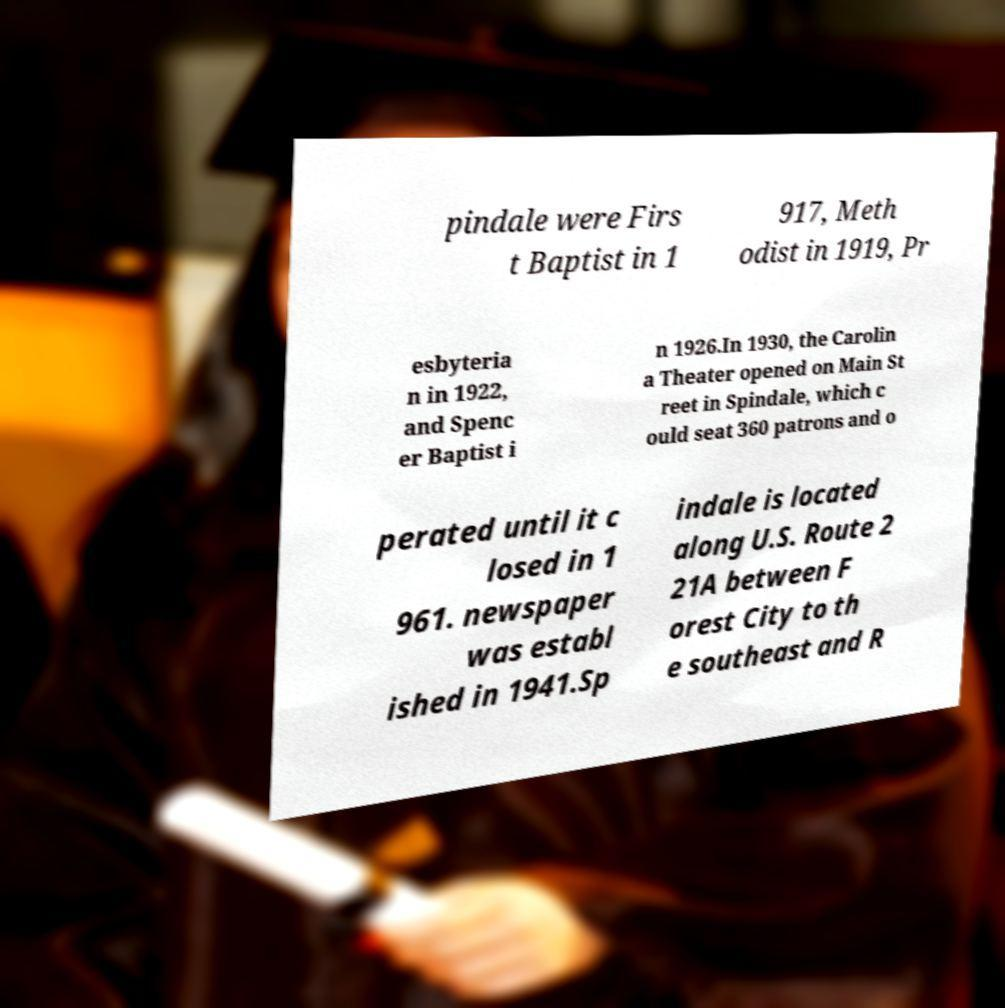Can you read and provide the text displayed in the image?This photo seems to have some interesting text. Can you extract and type it out for me? pindale were Firs t Baptist in 1 917, Meth odist in 1919, Pr esbyteria n in 1922, and Spenc er Baptist i n 1926.In 1930, the Carolin a Theater opened on Main St reet in Spindale, which c ould seat 360 patrons and o perated until it c losed in 1 961. newspaper was establ ished in 1941.Sp indale is located along U.S. Route 2 21A between F orest City to th e southeast and R 